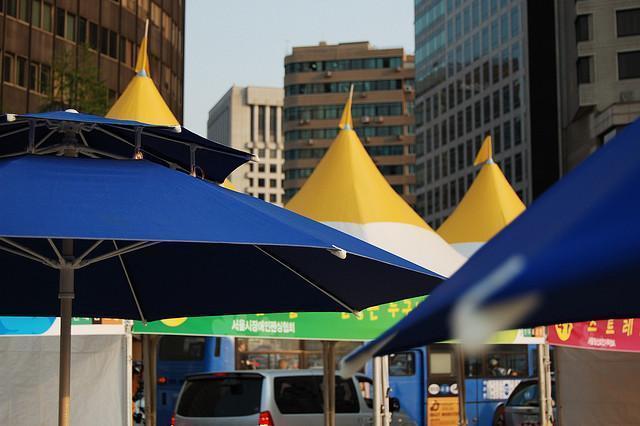How many umbrellas are there?
Give a very brief answer. 5. How many umbrellas are in the picture?
Give a very brief answer. 5. How many cows are there?
Give a very brief answer. 0. 